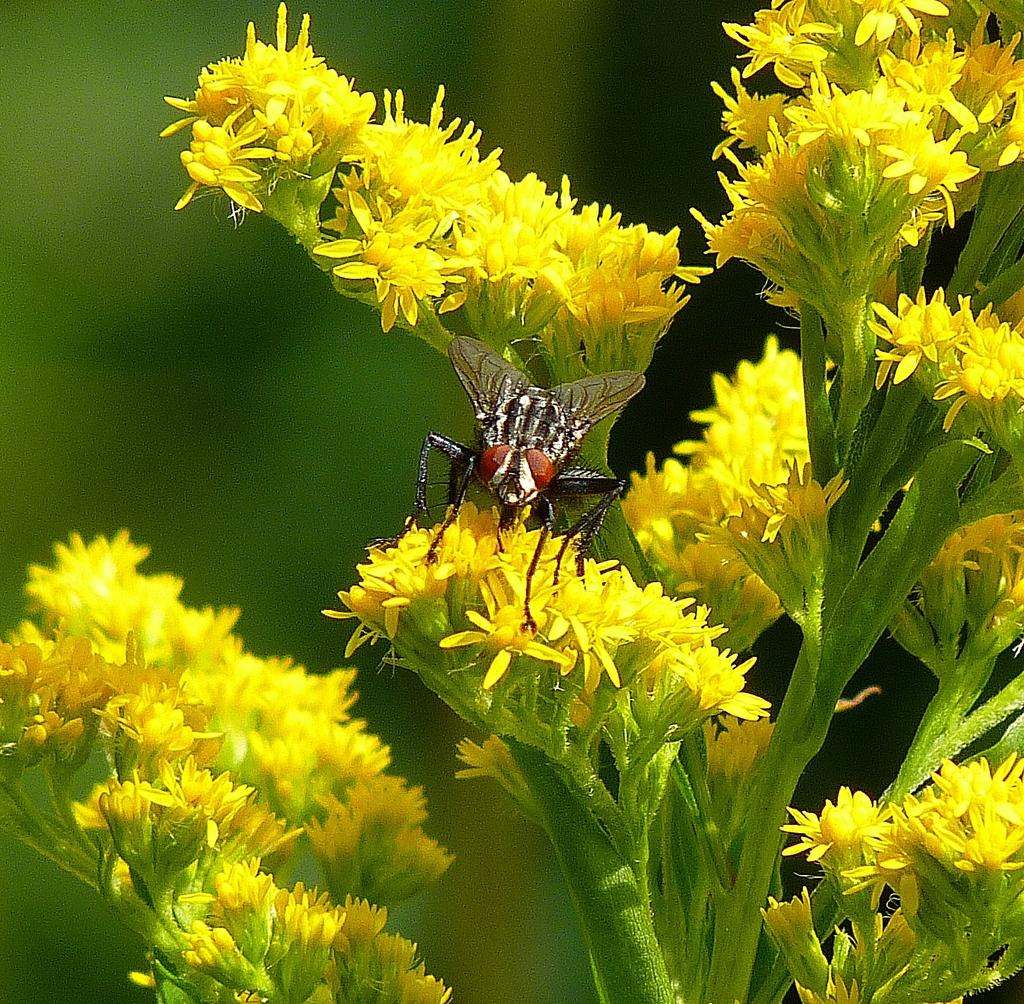What type of plant is depicted in the image? There are flowers on stems in the image. Are there any living creatures present in the image? Yes, an insect is visible on the flowers. How would you describe the background of the image? The background of the image is blurry. Can you tell me how many crackers are in the image? There are no crackers present in the image. How does the insect join the flowers in the image? The insect is already visible on the flowers in the image, so it does not need to join them. 